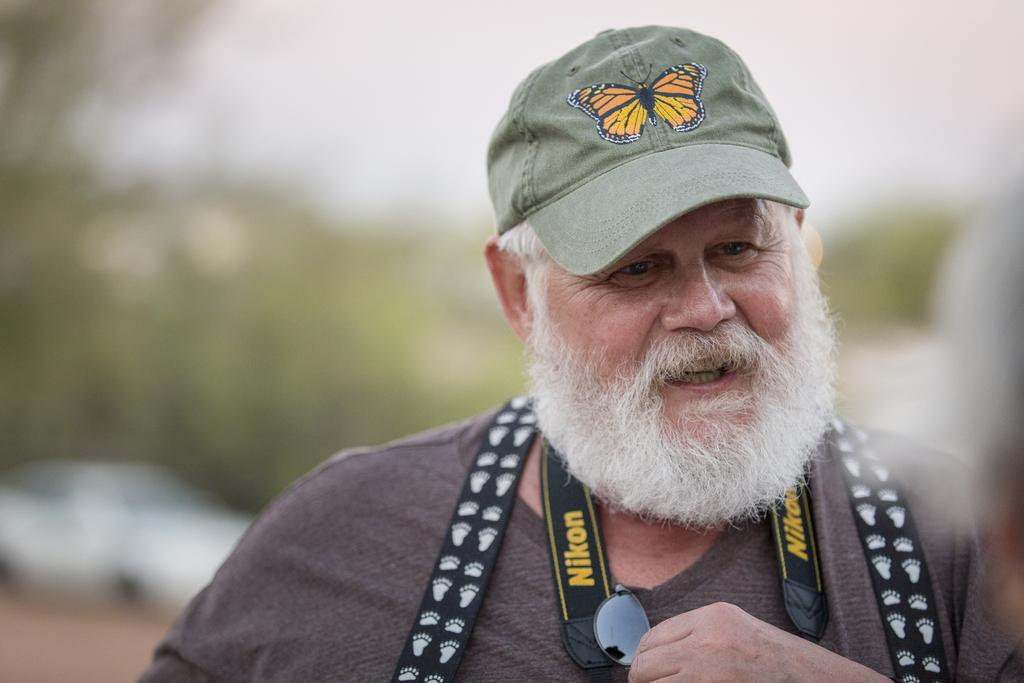Who is present in the image? There is a man in the image. What is the man wearing on his head? The man is wearing a cap. What is the man's facial expression? The man is smiling. What type of eyewear is the man wearing? The man is wearing goggles. What accessory is the man wearing around his waist? The man is wearing a belt. What can be seen in the background of the image? There is a white car and trees in the background of the image. How would you describe the background of the image? The background appears blurry. What type of sock is the man wearing in the image? There is no mention of socks in the provided facts, so we cannot determine if the man is wearing socks or what type they might be. 